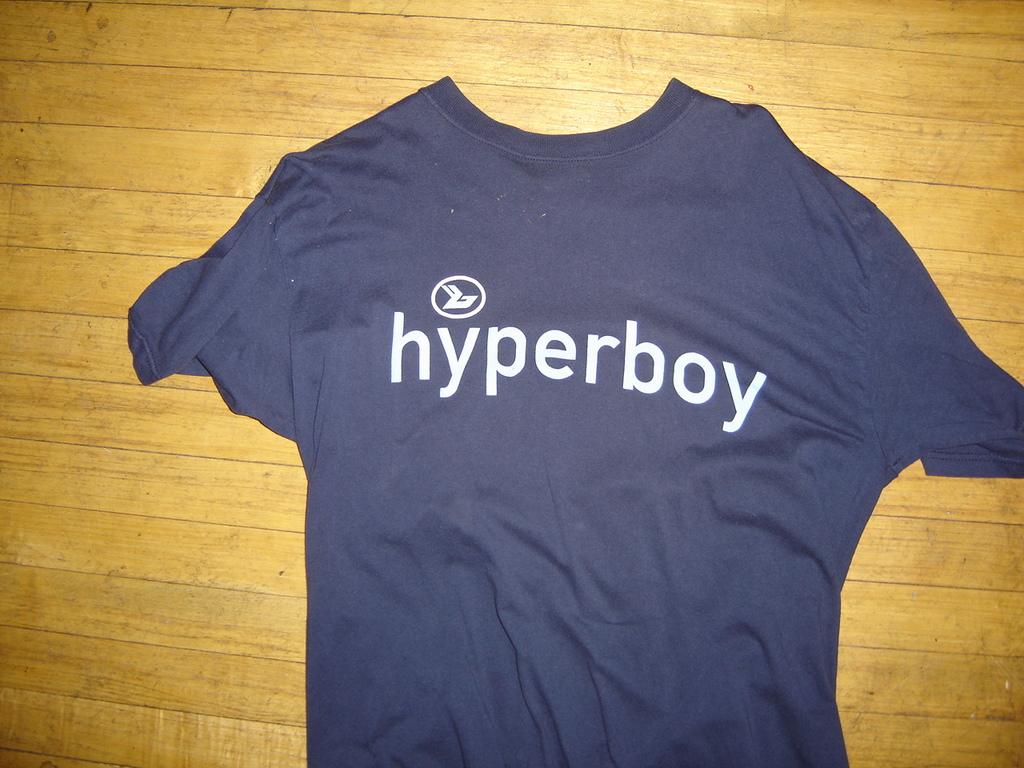Is the shirt blue and have a logo?
Give a very brief answer. Yes. 